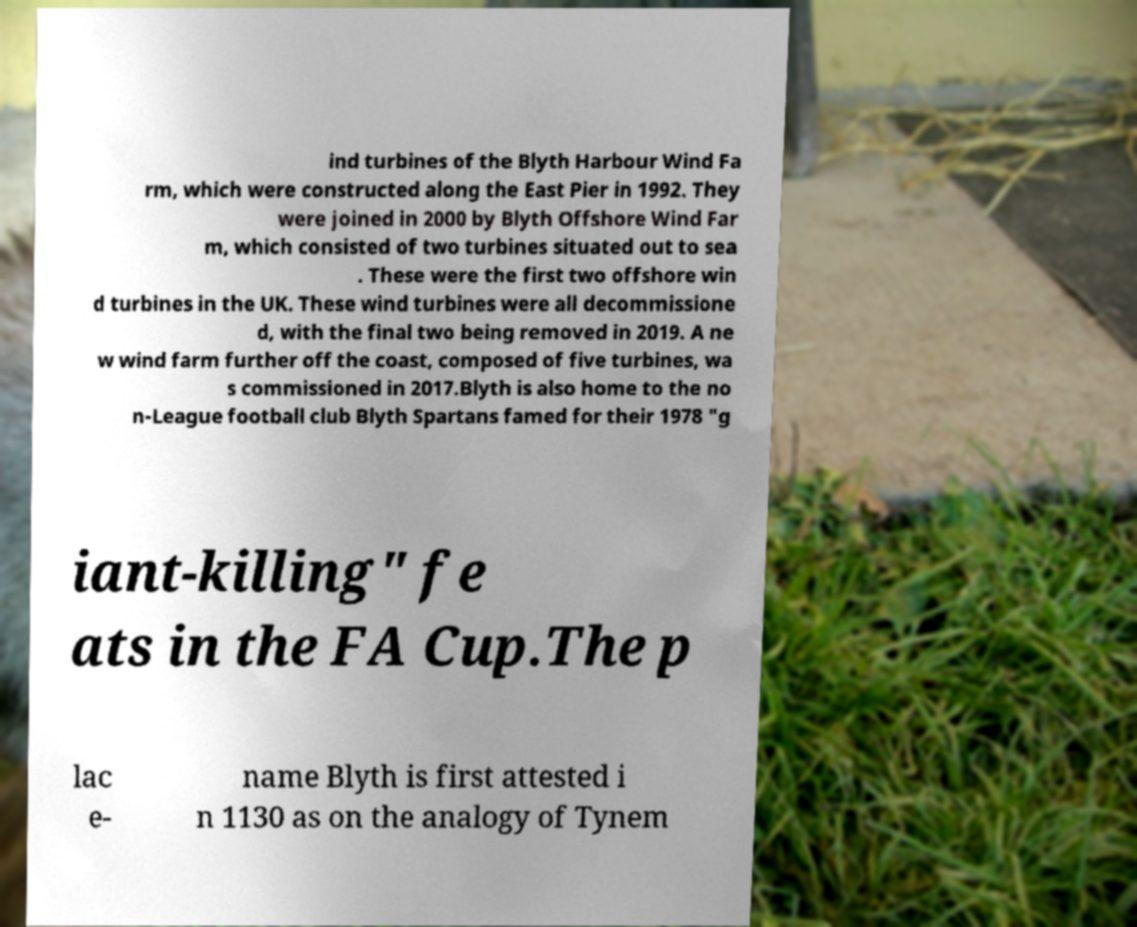Can you accurately transcribe the text from the provided image for me? ind turbines of the Blyth Harbour Wind Fa rm, which were constructed along the East Pier in 1992. They were joined in 2000 by Blyth Offshore Wind Far m, which consisted of two turbines situated out to sea . These were the first two offshore win d turbines in the UK. These wind turbines were all decommissione d, with the final two being removed in 2019. A ne w wind farm further off the coast, composed of five turbines, wa s commissioned in 2017.Blyth is also home to the no n-League football club Blyth Spartans famed for their 1978 "g iant-killing" fe ats in the FA Cup.The p lac e- name Blyth is first attested i n 1130 as on the analogy of Tynem 